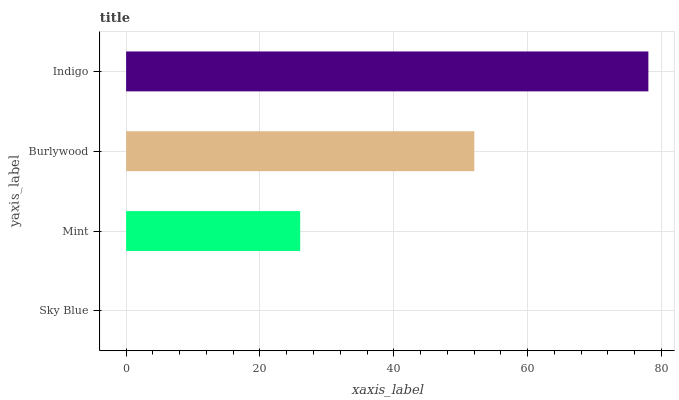Is Sky Blue the minimum?
Answer yes or no. Yes. Is Indigo the maximum?
Answer yes or no. Yes. Is Mint the minimum?
Answer yes or no. No. Is Mint the maximum?
Answer yes or no. No. Is Mint greater than Sky Blue?
Answer yes or no. Yes. Is Sky Blue less than Mint?
Answer yes or no. Yes. Is Sky Blue greater than Mint?
Answer yes or no. No. Is Mint less than Sky Blue?
Answer yes or no. No. Is Burlywood the high median?
Answer yes or no. Yes. Is Mint the low median?
Answer yes or no. Yes. Is Mint the high median?
Answer yes or no. No. Is Sky Blue the low median?
Answer yes or no. No. 